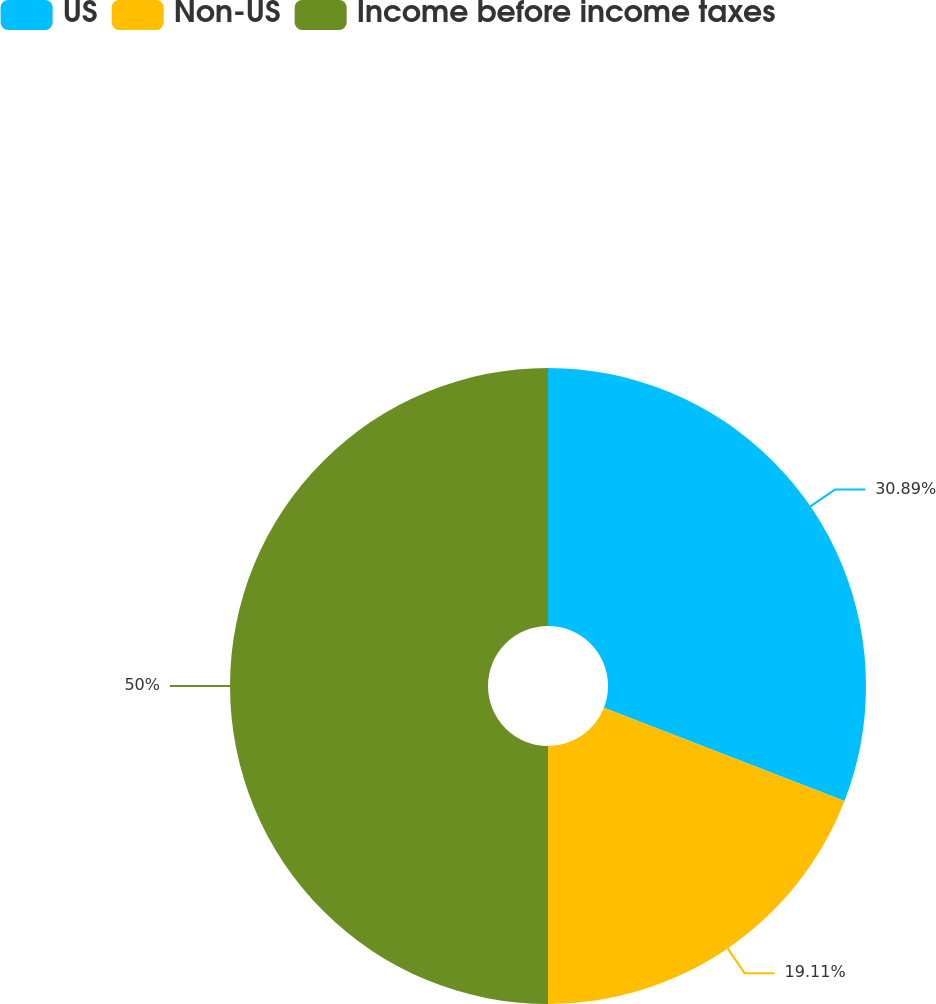<chart> <loc_0><loc_0><loc_500><loc_500><pie_chart><fcel>US<fcel>Non-US<fcel>Income before income taxes<nl><fcel>30.89%<fcel>19.11%<fcel>50.0%<nl></chart> 